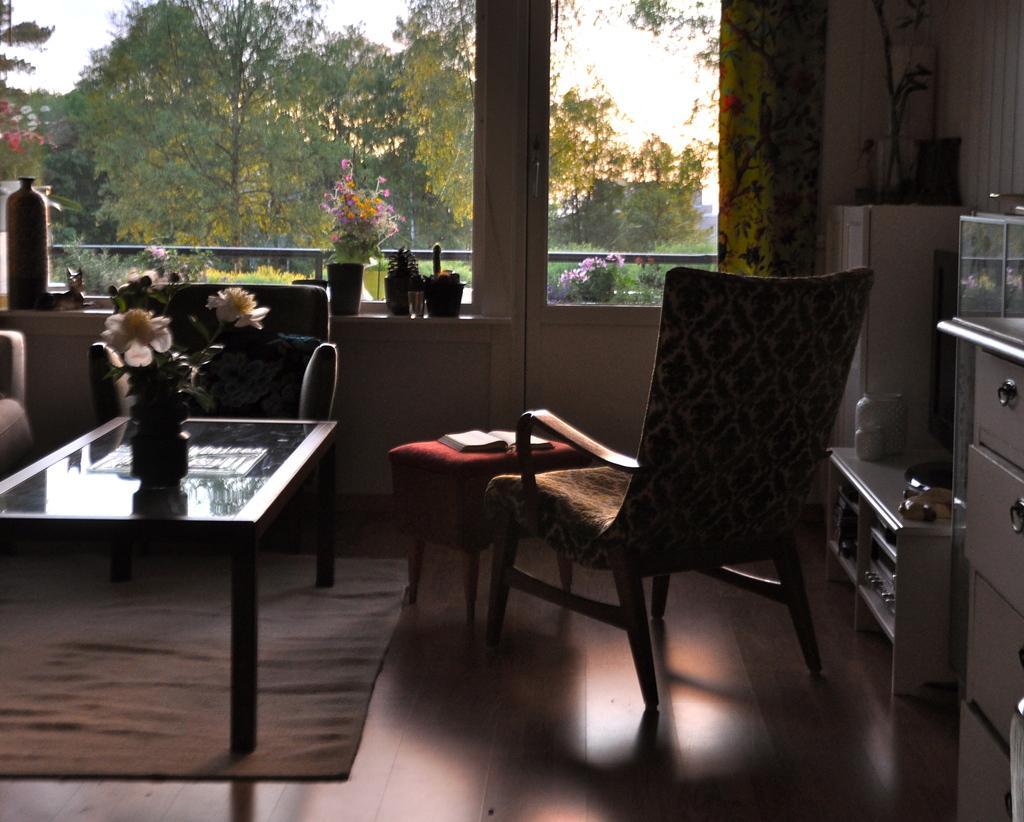Can you describe this image briefly? This is inside of the room we can see chairs and tables,furniture on the floor,on the table we can see book,flower. We can see glass window,plants,pots,bottle,from this glass window we can see trees,sky. 